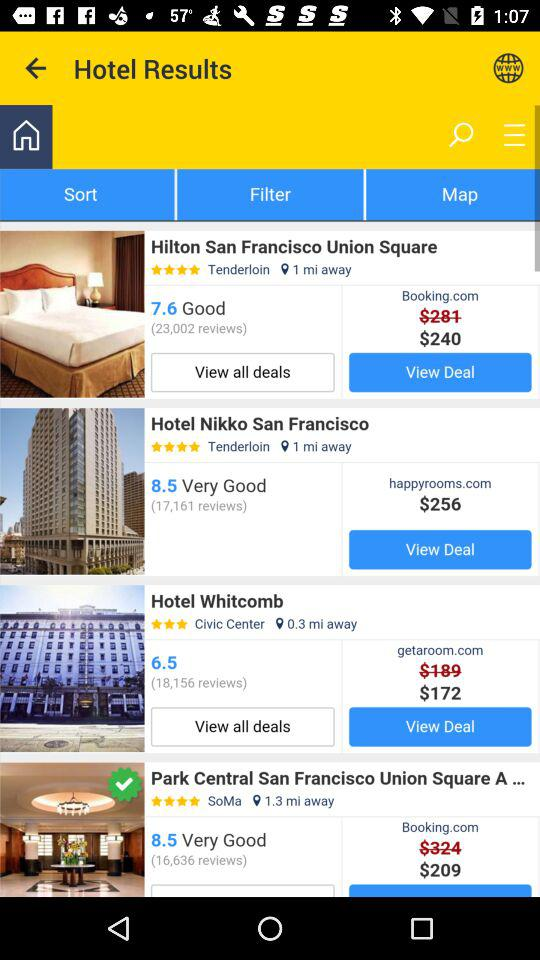What is the price of the Hotel Whitcomb? The price is $172. 